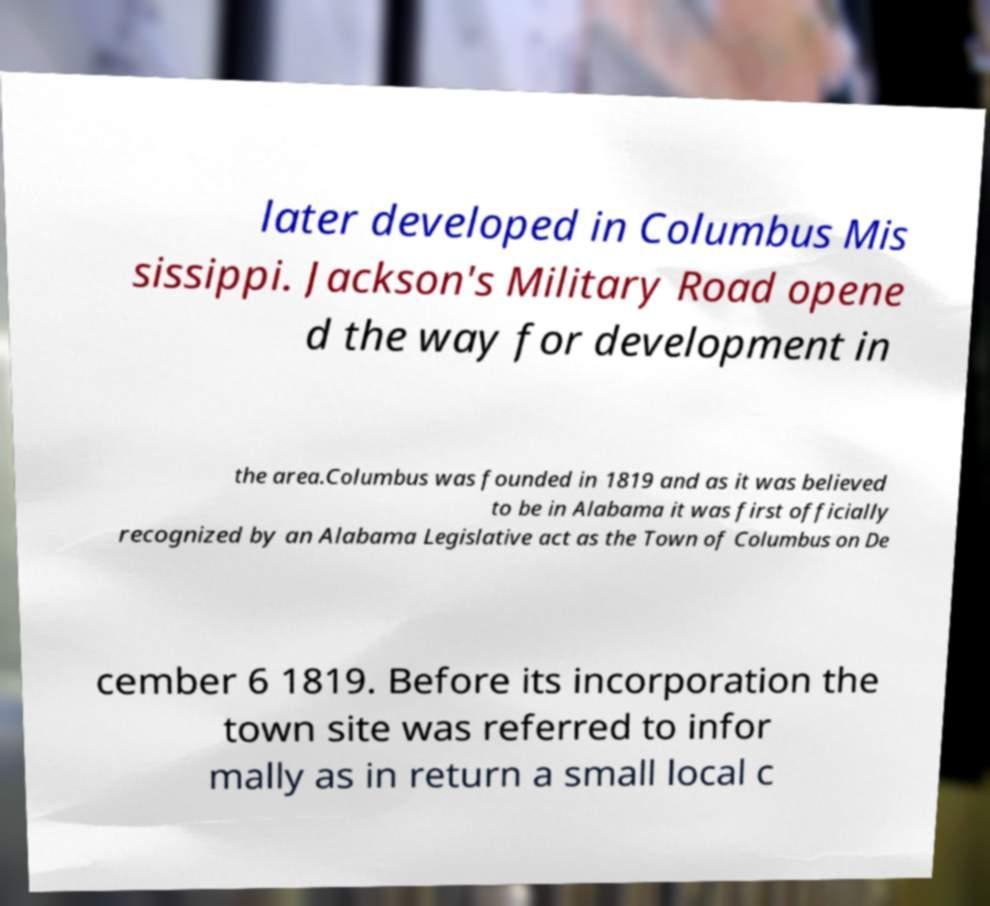Can you accurately transcribe the text from the provided image for me? later developed in Columbus Mis sissippi. Jackson's Military Road opene d the way for development in the area.Columbus was founded in 1819 and as it was believed to be in Alabama it was first officially recognized by an Alabama Legislative act as the Town of Columbus on De cember 6 1819. Before its incorporation the town site was referred to infor mally as in return a small local c 